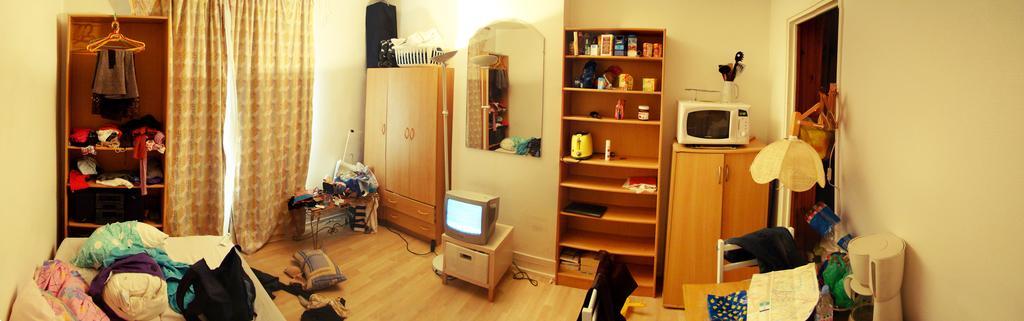Could you give a brief overview of what you see in this image? This is a picture taken inside a room. On the left there are pillows, bed, clothes, curtains, wall and wardrobe. In the middle of the picture we can see clothes, table, desk, television, cables, bureau, wall and other objects. On the right there are closet, wardrobe, chair, table, lamp, clothes, wall, door and various objects. In the middle of the picture we can see a mirror. 